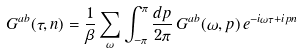Convert formula to latex. <formula><loc_0><loc_0><loc_500><loc_500>G ^ { a b } ( \tau , n ) = \frac { 1 } { \beta } \sum _ { \omega } \int _ { - \pi } ^ { \pi } \frac { d p } { 2 \pi } \, G ^ { a b } ( \omega , p ) \, e ^ { - i \omega \tau + i p n }</formula> 